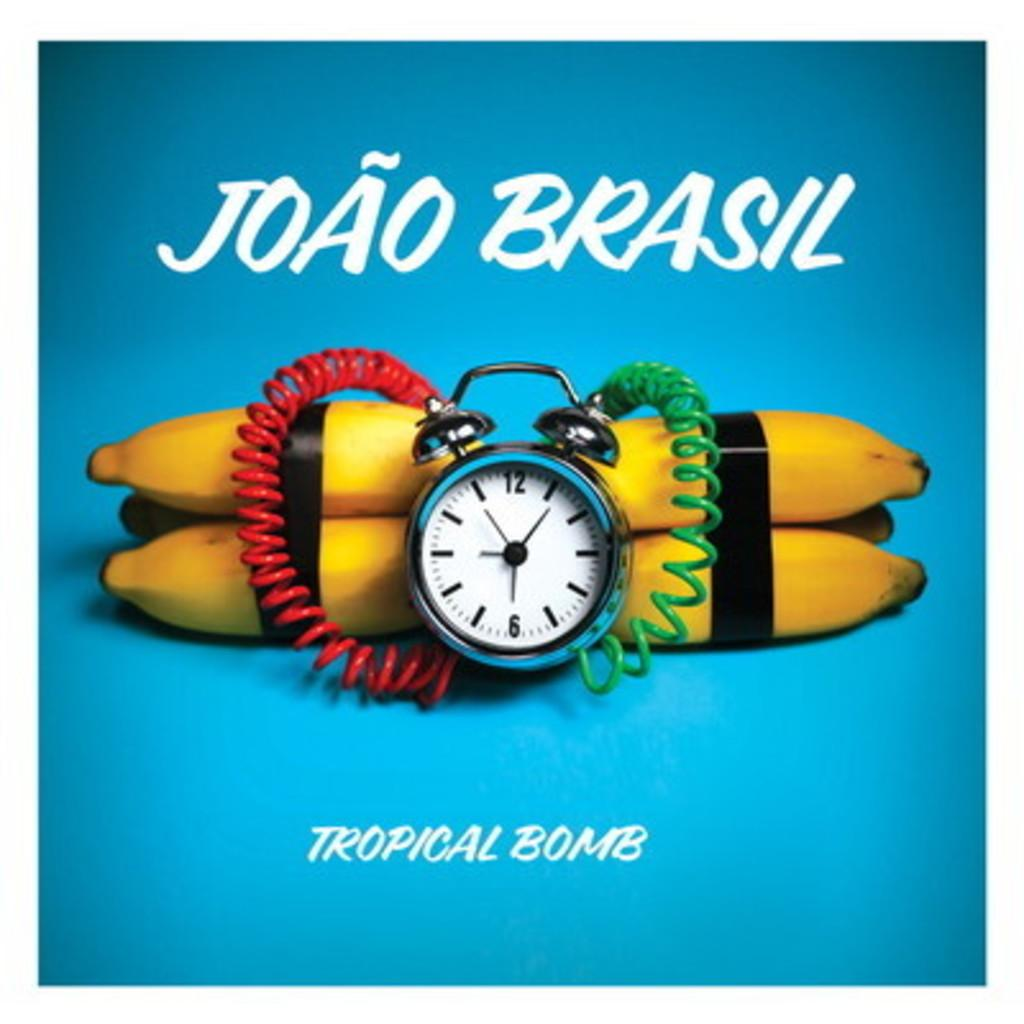<image>
Present a compact description of the photo's key features. Some bananas are wired like a bomb with the caption Tropical Bomb. 